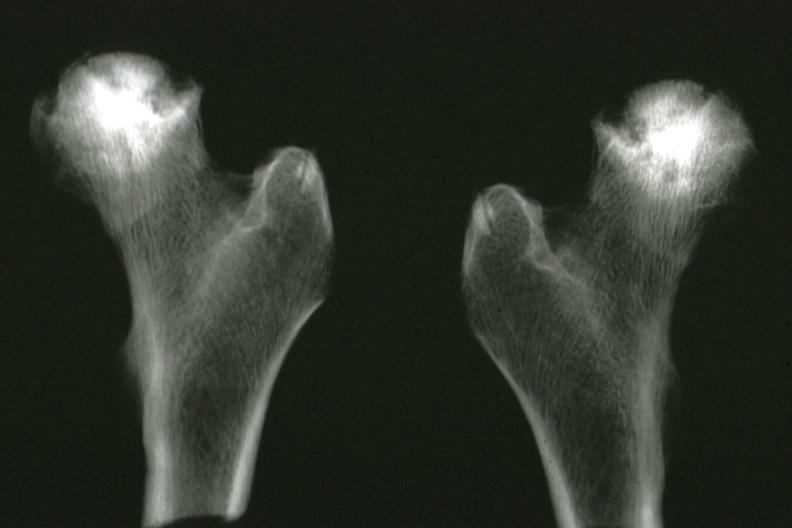how is x-ray of femoral heads removed at good illustration?
Answer the question using a single word or phrase. Autopsy 